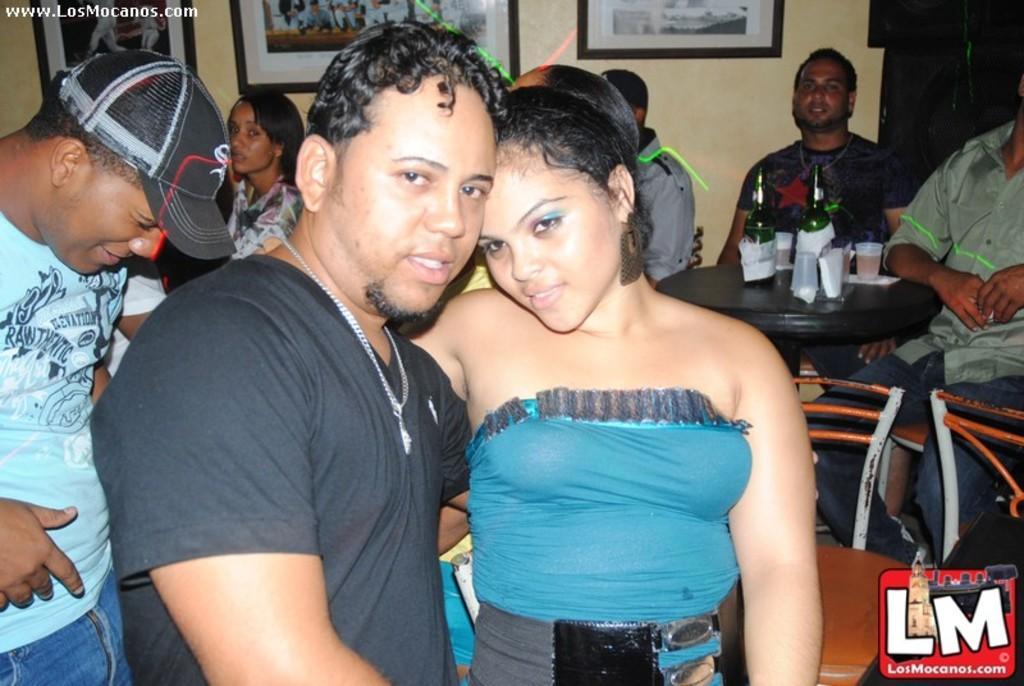Can you describe this image briefly? On the left a man is wearing a cap and standing in the middle a man and a girl are standing together on the right there are wine bottles on a table. 